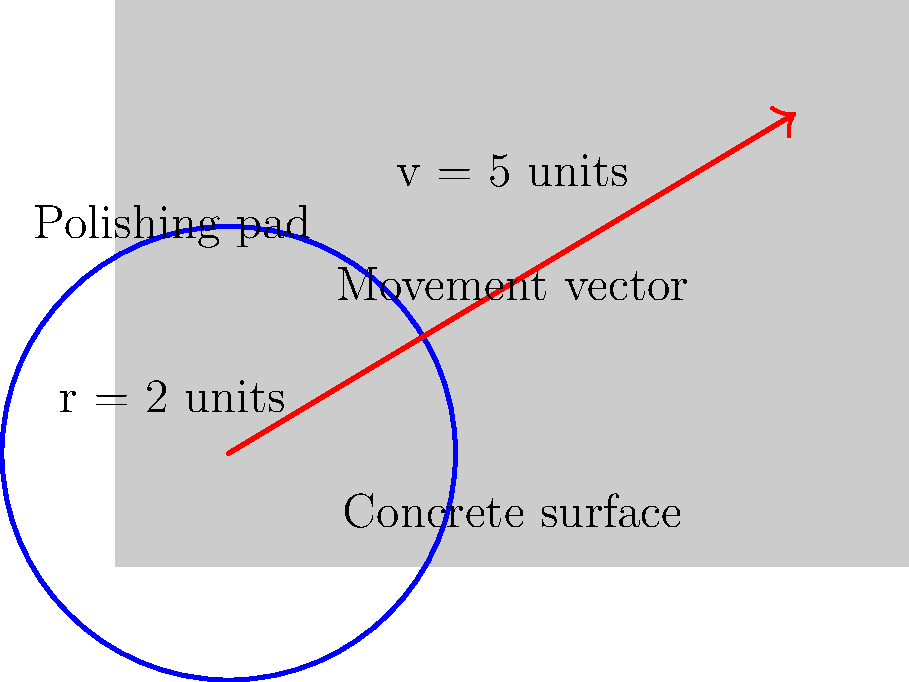A circular concrete polishing pad with a radius of 2 units moves in a straight line across a flat surface. The movement vector has a magnitude of 5 units. Calculate the total area covered by the polishing pad during its movement. To solve this problem, we need to follow these steps:

1. Recognize that the area covered by the polishing pad forms a stadium shape (also known as a discorectangle).

2. The stadium shape consists of a rectangle and two semicircles at the ends.

3. Calculate the area of the rectangle:
   - Length of rectangle = magnitude of movement vector = 5 units
   - Width of rectangle = diameter of polishing pad = 2 * radius = 2 * 2 = 4 units
   - Area of rectangle = $5 * 4 = 20$ square units

4. Calculate the area of one semicircle:
   - Area of full circle = $\pi r^2 = \pi * 2^2 = 4\pi$ square units
   - Area of semicircle = $\frac{1}{2} * 4\pi = 2\pi$ square units

5. Total area covered:
   - Area = Rectangle + 2 * Semicircle
   - Area = $20 + 2 * 2\pi = 20 + 4\pi$ square units

Therefore, the total area covered by the polishing pad is $20 + 4\pi$ square units.
Answer: $20 + 4\pi$ square units 